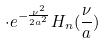<formula> <loc_0><loc_0><loc_500><loc_500>\cdot e ^ { - \frac { \nu ^ { 2 } } { 2 a ^ { 2 } } } H _ { n } ( \frac { \nu } { a } )</formula> 